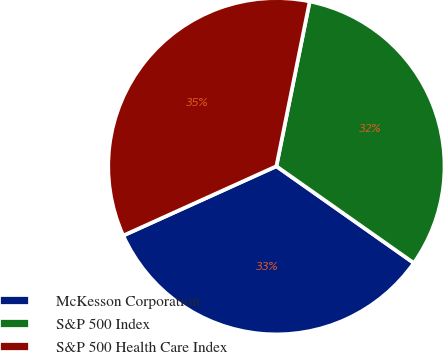Convert chart. <chart><loc_0><loc_0><loc_500><loc_500><pie_chart><fcel>McKesson Corporation<fcel>S&P 500 Index<fcel>S&P 500 Health Care Index<nl><fcel>33.47%<fcel>31.59%<fcel>34.94%<nl></chart> 